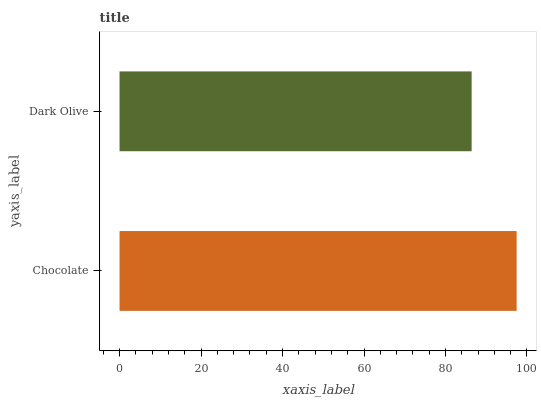Is Dark Olive the minimum?
Answer yes or no. Yes. Is Chocolate the maximum?
Answer yes or no. Yes. Is Dark Olive the maximum?
Answer yes or no. No. Is Chocolate greater than Dark Olive?
Answer yes or no. Yes. Is Dark Olive less than Chocolate?
Answer yes or no. Yes. Is Dark Olive greater than Chocolate?
Answer yes or no. No. Is Chocolate less than Dark Olive?
Answer yes or no. No. Is Chocolate the high median?
Answer yes or no. Yes. Is Dark Olive the low median?
Answer yes or no. Yes. Is Dark Olive the high median?
Answer yes or no. No. Is Chocolate the low median?
Answer yes or no. No. 